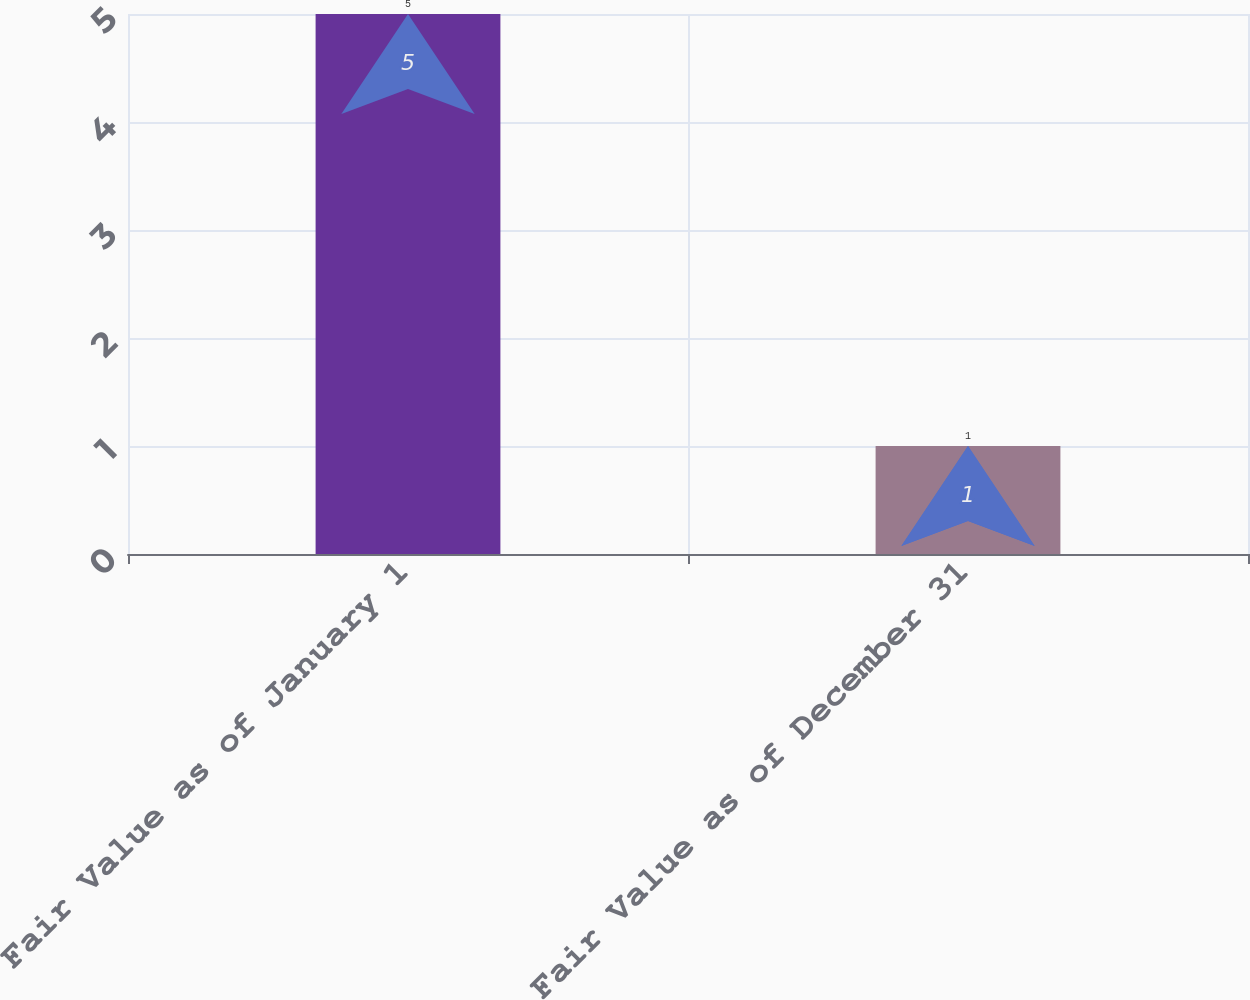Convert chart to OTSL. <chart><loc_0><loc_0><loc_500><loc_500><bar_chart><fcel>Fair Value as of January 1<fcel>Fair Value as of December 31<nl><fcel>5<fcel>1<nl></chart> 